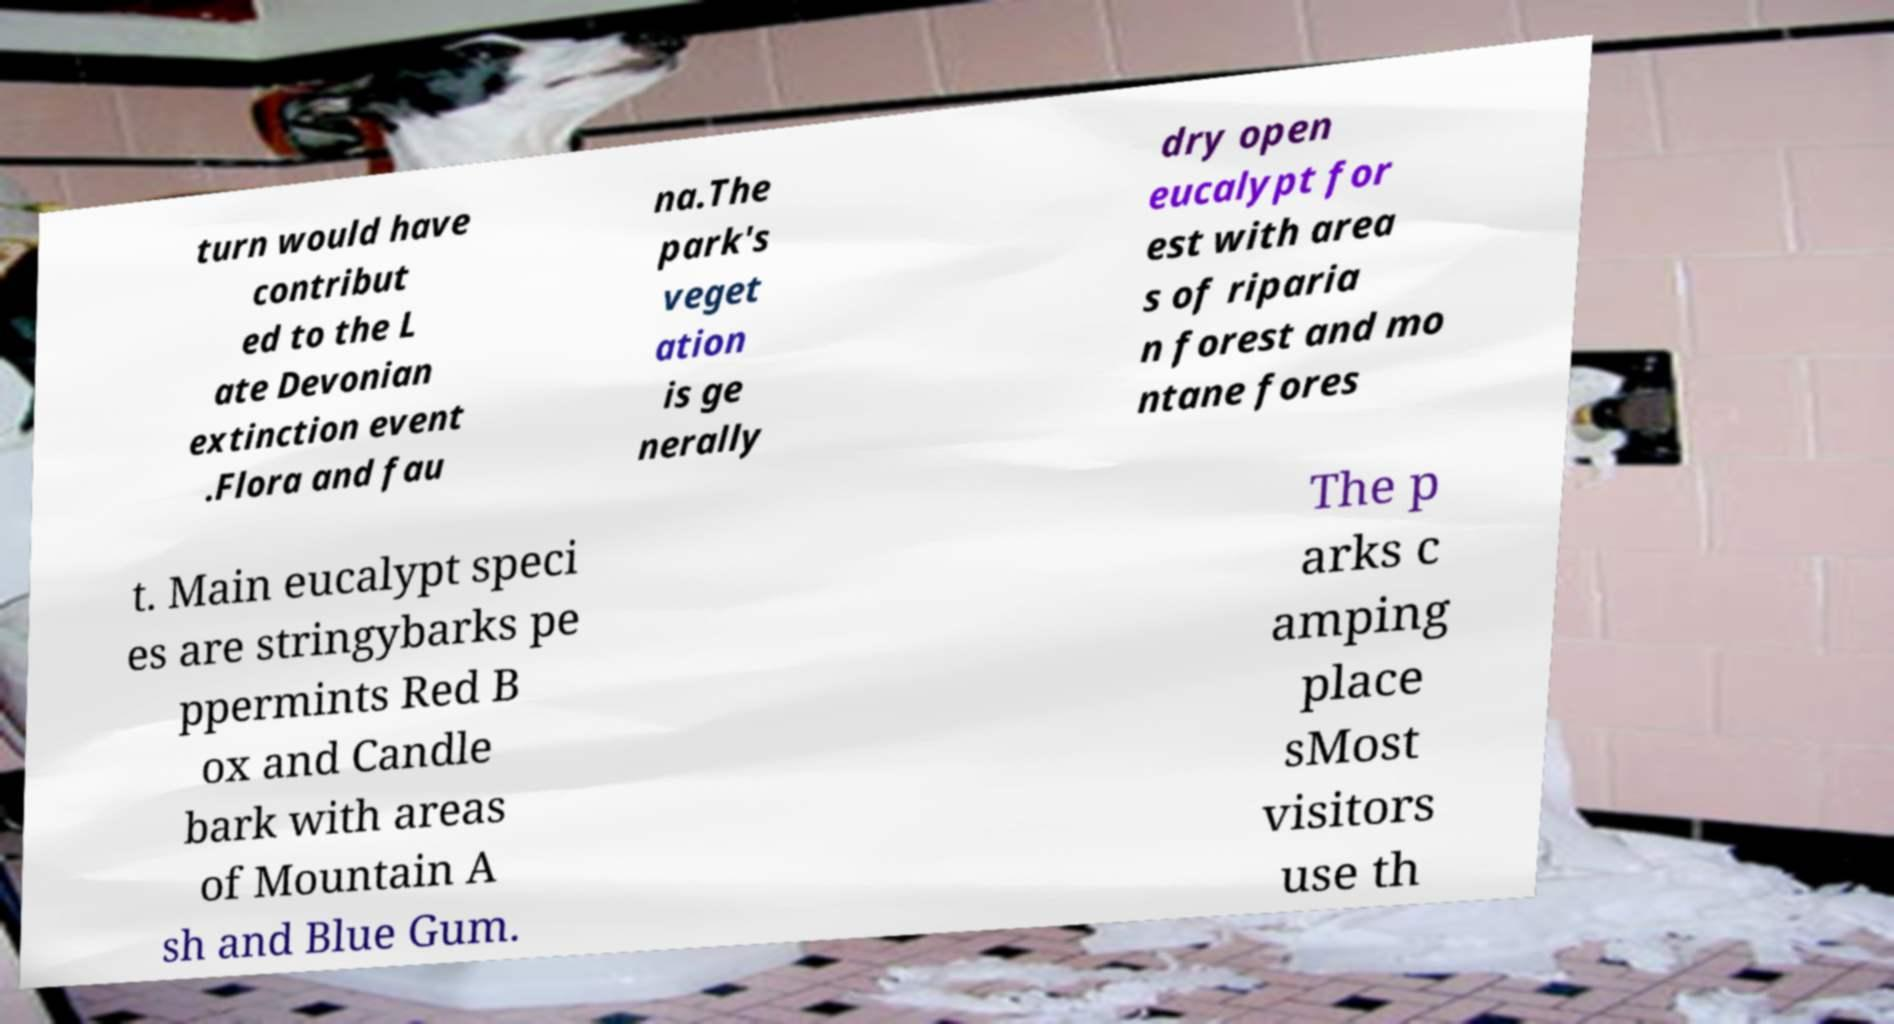Could you extract and type out the text from this image? turn would have contribut ed to the L ate Devonian extinction event .Flora and fau na.The park's veget ation is ge nerally dry open eucalypt for est with area s of riparia n forest and mo ntane fores t. Main eucalypt speci es are stringybarks pe ppermints Red B ox and Candle bark with areas of Mountain A sh and Blue Gum. The p arks c amping place sMost visitors use th 